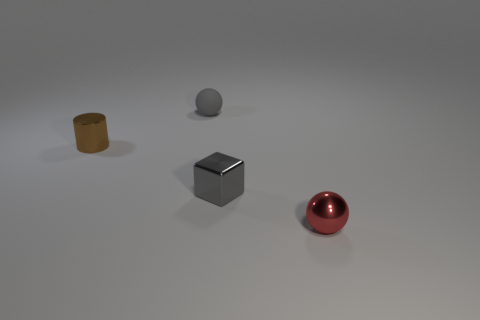Add 3 small brown rubber blocks. How many objects exist? 7 Subtract all cylinders. How many objects are left? 3 Add 4 tiny red balls. How many tiny red balls exist? 5 Subtract 0 cyan blocks. How many objects are left? 4 Subtract all gray metallic things. Subtract all brown cylinders. How many objects are left? 2 Add 1 gray balls. How many gray balls are left? 2 